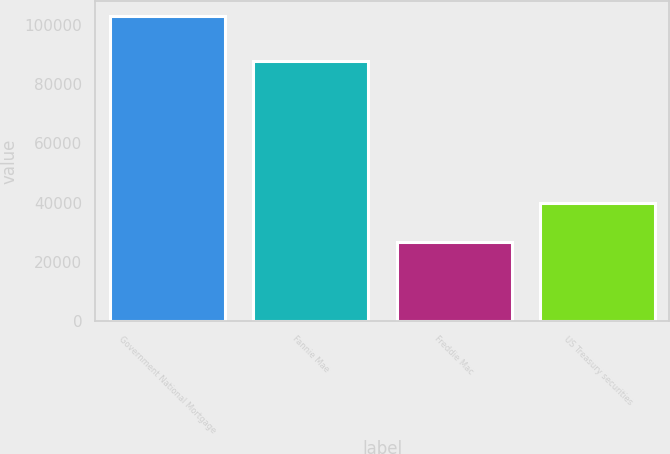<chart> <loc_0><loc_0><loc_500><loc_500><bar_chart><fcel>Government National Mortgage<fcel>Fannie Mae<fcel>Freddie Mac<fcel>US Treasury securities<nl><fcel>102960<fcel>87898<fcel>26617<fcel>39946<nl></chart> 